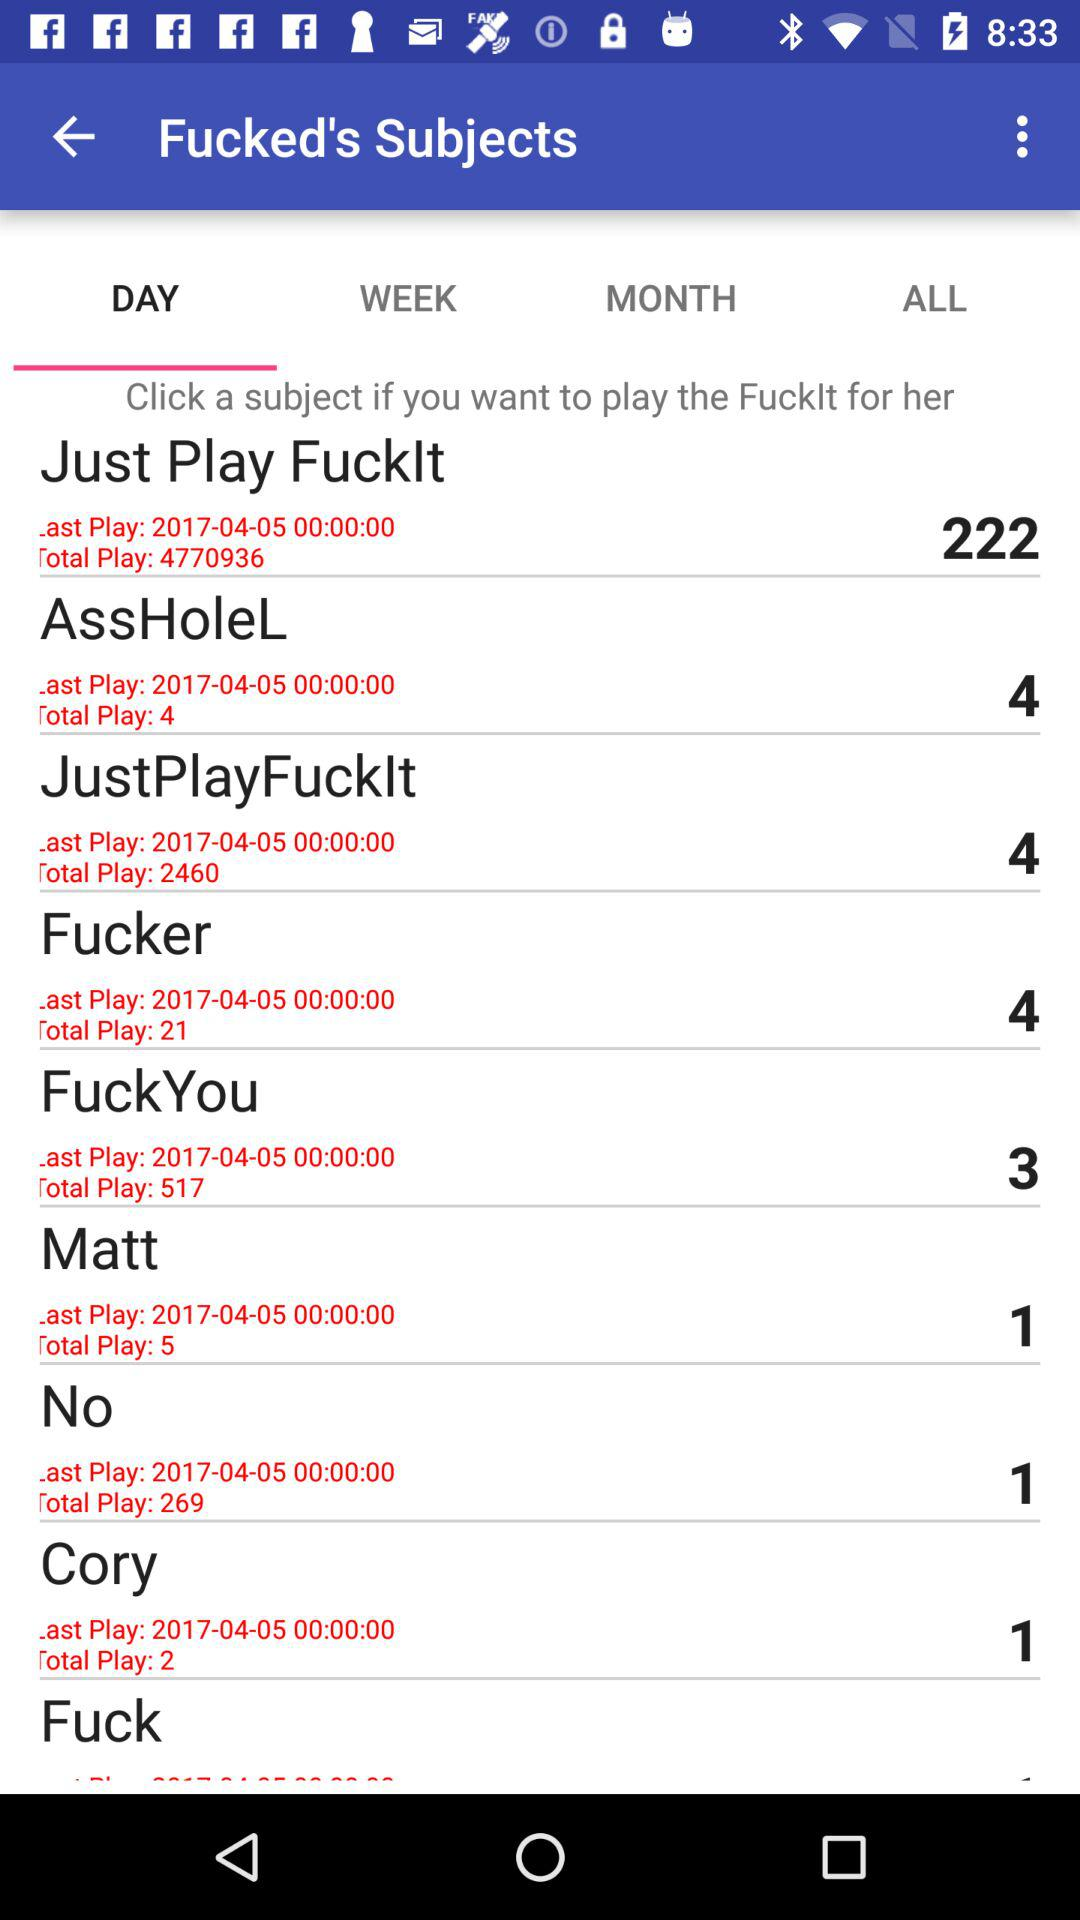What is the total play number of "Just Play Fucklt"? The total play number is 4770936. 